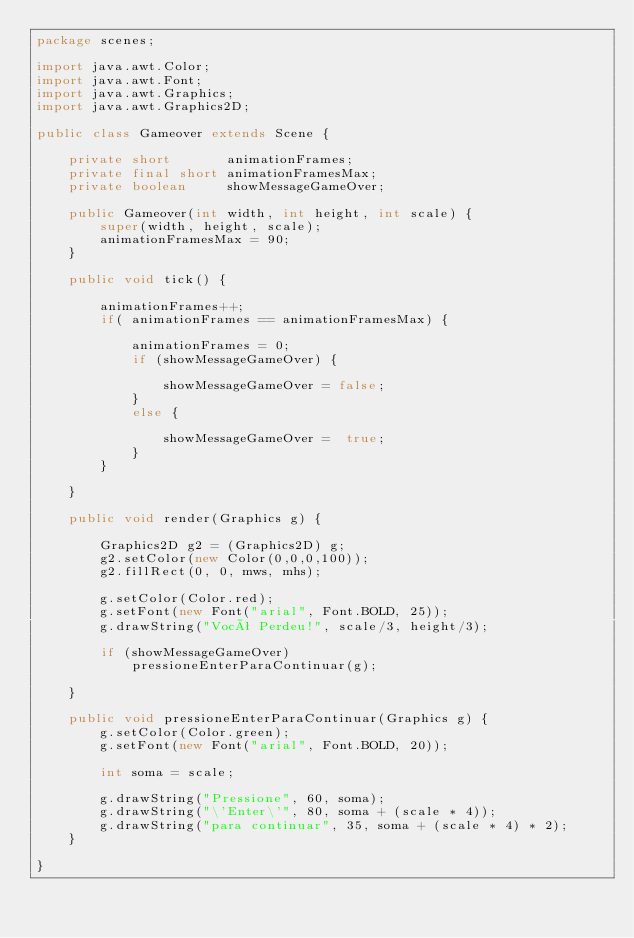<code> <loc_0><loc_0><loc_500><loc_500><_Java_>package scenes;

import java.awt.Color;
import java.awt.Font;
import java.awt.Graphics;
import java.awt.Graphics2D;

public class Gameover extends Scene {
	
	private short       animationFrames;
	private final short animationFramesMax;
	private boolean     showMessageGameOver;

	public Gameover(int width, int height, int scale) {
		super(width, height, scale);
		animationFramesMax = 90;
	}
	
	public void tick() {
		
		animationFrames++;
		if( animationFrames == animationFramesMax) {
			
			animationFrames = 0;
			if (showMessageGameOver) {
				
				showMessageGameOver = false;
			}
			else {
				
				showMessageGameOver =  true;
			}
		}

	}
	
	public void render(Graphics g) {
		
		Graphics2D g2 = (Graphics2D) g;
		g2.setColor(new Color(0,0,0,100));
		g2.fillRect(0, 0, mws, mhs);
		
		g.setColor(Color.red);
		g.setFont(new Font("arial", Font.BOLD, 25));
		g.drawString("Você Perdeu!", scale/3, height/3);
		
		if (showMessageGameOver) 
			pressioneEnterParaContinuar(g);
		
	}
	
	public void pressioneEnterParaContinuar(Graphics g) {
		g.setColor(Color.green);
		g.setFont(new Font("arial", Font.BOLD, 20));
		
		int soma = scale;
		
		g.drawString("Pressione", 60, soma);
		g.drawString("\'Enter\'", 80, soma + (scale * 4));
		g.drawString("para continuar", 35, soma + (scale * 4) * 2);
	}

}
</code> 